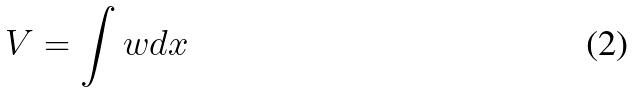<formula> <loc_0><loc_0><loc_500><loc_500>V = \int w d x</formula> 